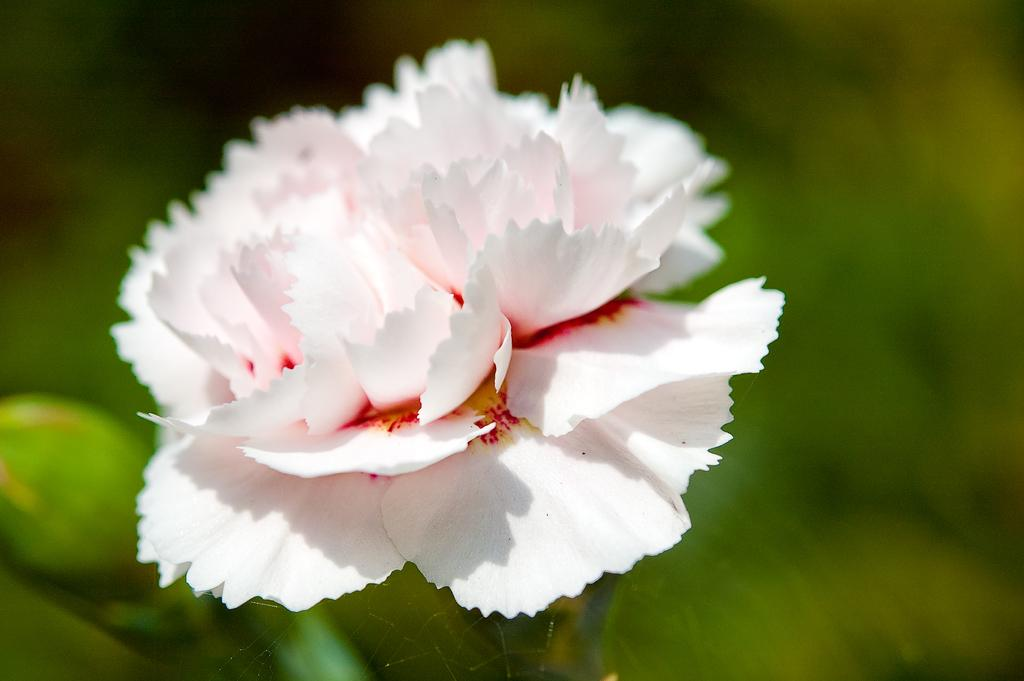What is the main subject of the image? There is a flower in the image. Can you describe the flower's stage of growth? There is a bud on the left side of the image. How would you describe the background of the image? The background of the image is blurred. How many fish can be seen swimming in the image? There are no fish present in the image; it features a flower and a bud. What type of card is visible in the image? There is no card present in the image; it only contains a flower and a bud. 